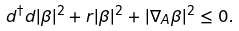<formula> <loc_0><loc_0><loc_500><loc_500>d ^ { \dag } d | \beta | ^ { 2 } + r | \beta | ^ { 2 } + | \nabla _ { A } \beta | ^ { 2 } \leq 0 .</formula> 